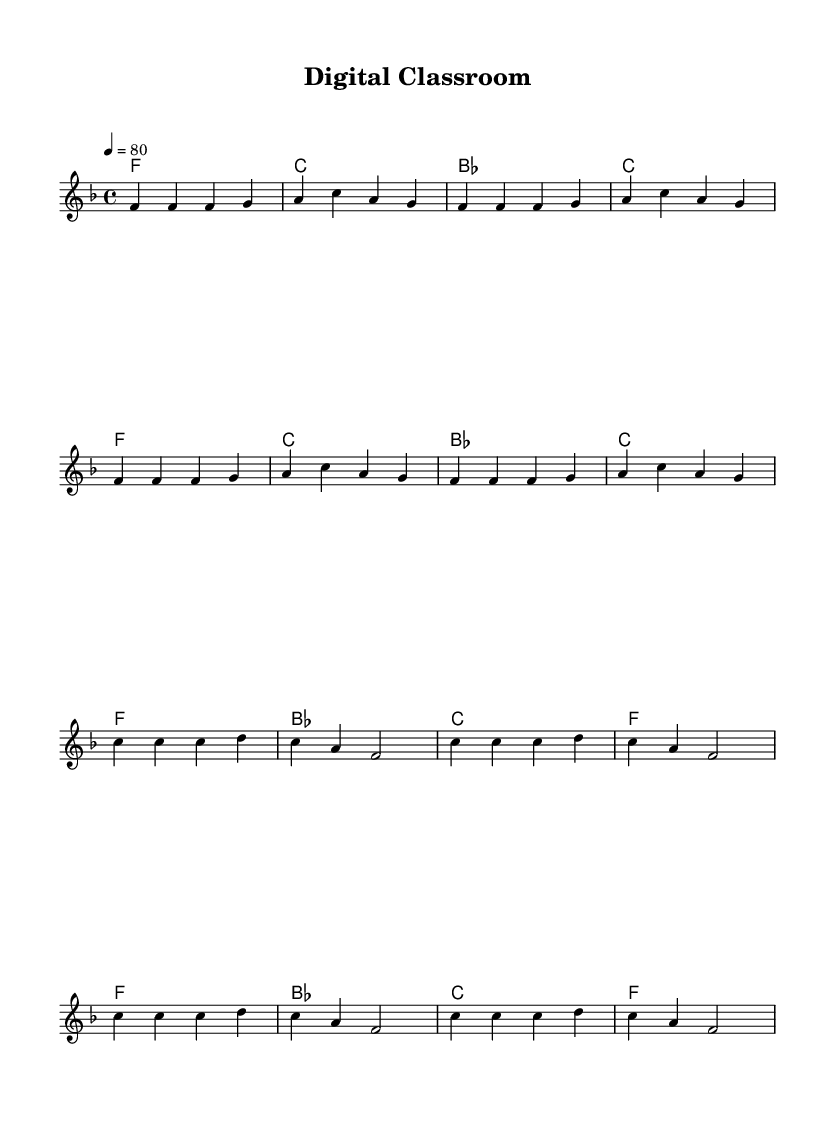What is the time signature of this music? The time signature is indicated at the beginning of the score and shows four beats per measure, which is commonly written as 4/4.
Answer: 4/4 What is the key signature of the piece? The key signature shown at the beginning of the staff has one flat, indicating that the piece is in F major.
Answer: F major What is the tempo marking for this piece? The tempo marking, which indicates the speed of the music, shows "4 = 80", meaning there are 80 beats per minute.
Answer: 80 How many measures are in the verse section? To determine the number of measures in the verse, we count the measures written directly in the score for that section; there are 8 measures in total for the verse.
Answer: 8 What is the total number of chords used in the piece? Looking at the chord section, we see four unique chords repeated throughout the measures: F, C, B-flat, and C. The total number of different chords listed is four.
Answer: 4 What genre does this piece belong to? The lyrical content, structure, and rhythmic style, along with the title "Digital Classroom," indicate that it falls under the Rhythm and Blues genre.
Answer: Rhythm and Blues What does the chorus repeat in terms of lyric structure? The chorus section shows that the same lyrical pattern is used, repeating lines that emphasize the interaction between digital learning and education, specifically 'Digital classroom' appears in each iteration.
Answer: 'Digital classroom' 